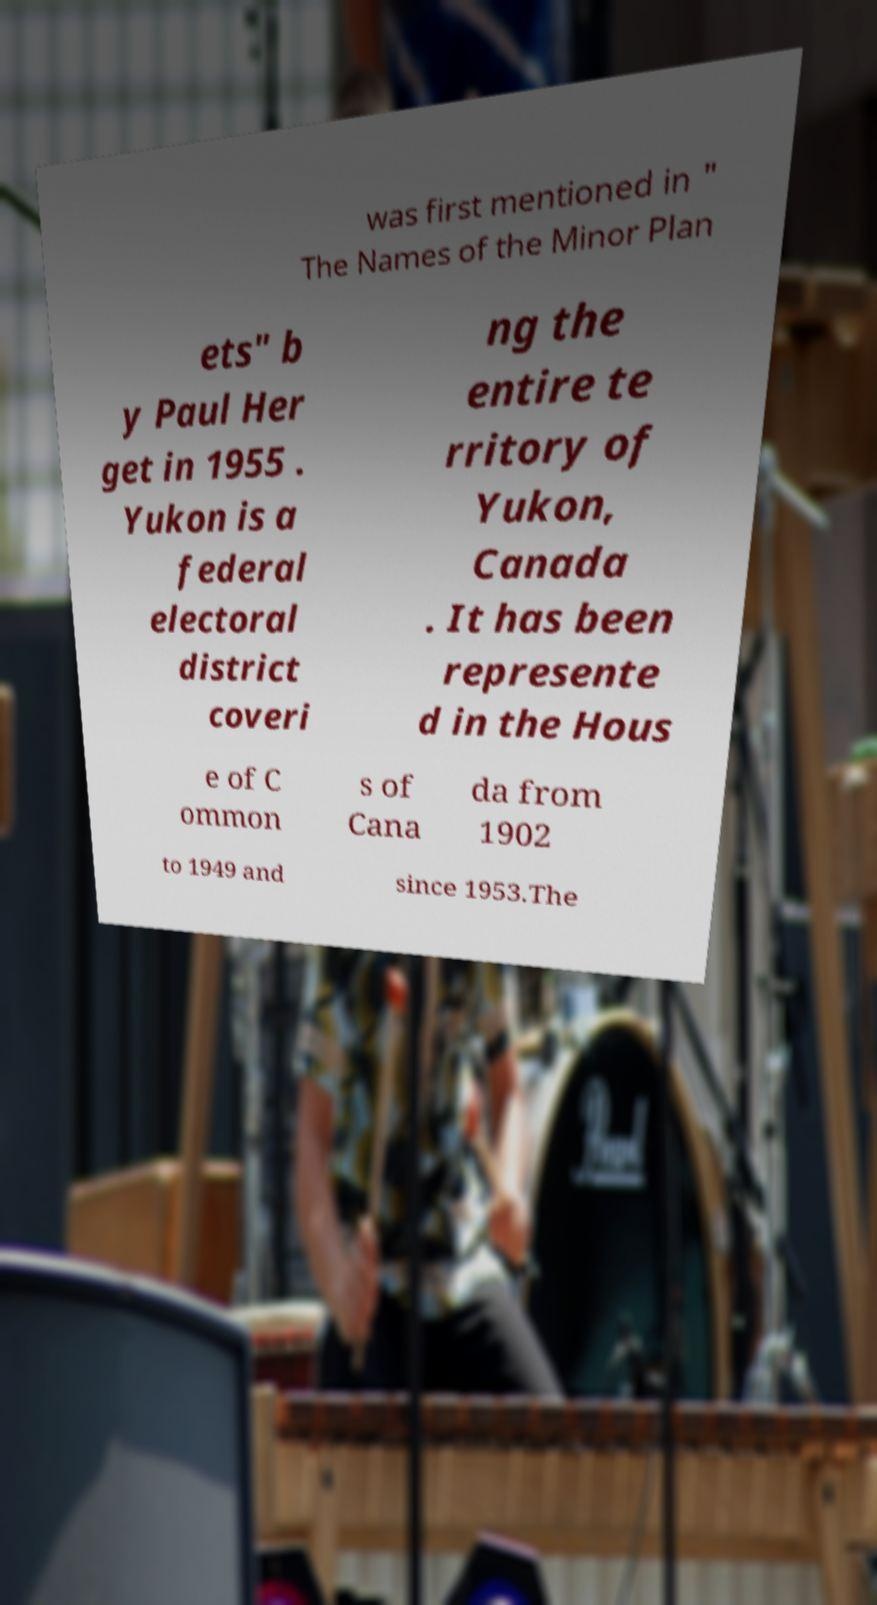Can you read and provide the text displayed in the image?This photo seems to have some interesting text. Can you extract and type it out for me? was first mentioned in " The Names of the Minor Plan ets" b y Paul Her get in 1955 . Yukon is a federal electoral district coveri ng the entire te rritory of Yukon, Canada . It has been represente d in the Hous e of C ommon s of Cana da from 1902 to 1949 and since 1953.The 